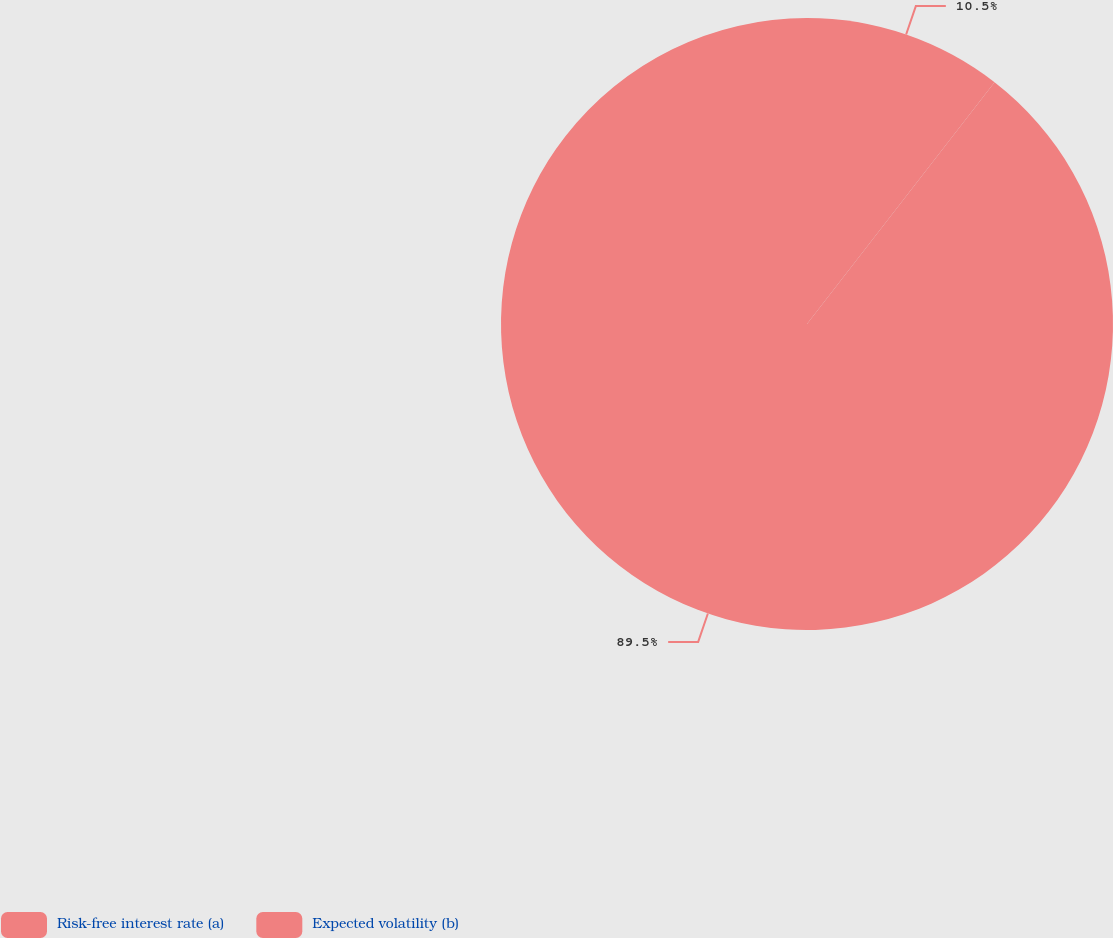<chart> <loc_0><loc_0><loc_500><loc_500><pie_chart><fcel>Risk-free interest rate (a)<fcel>Expected volatility (b)<nl><fcel>10.5%<fcel>89.5%<nl></chart> 